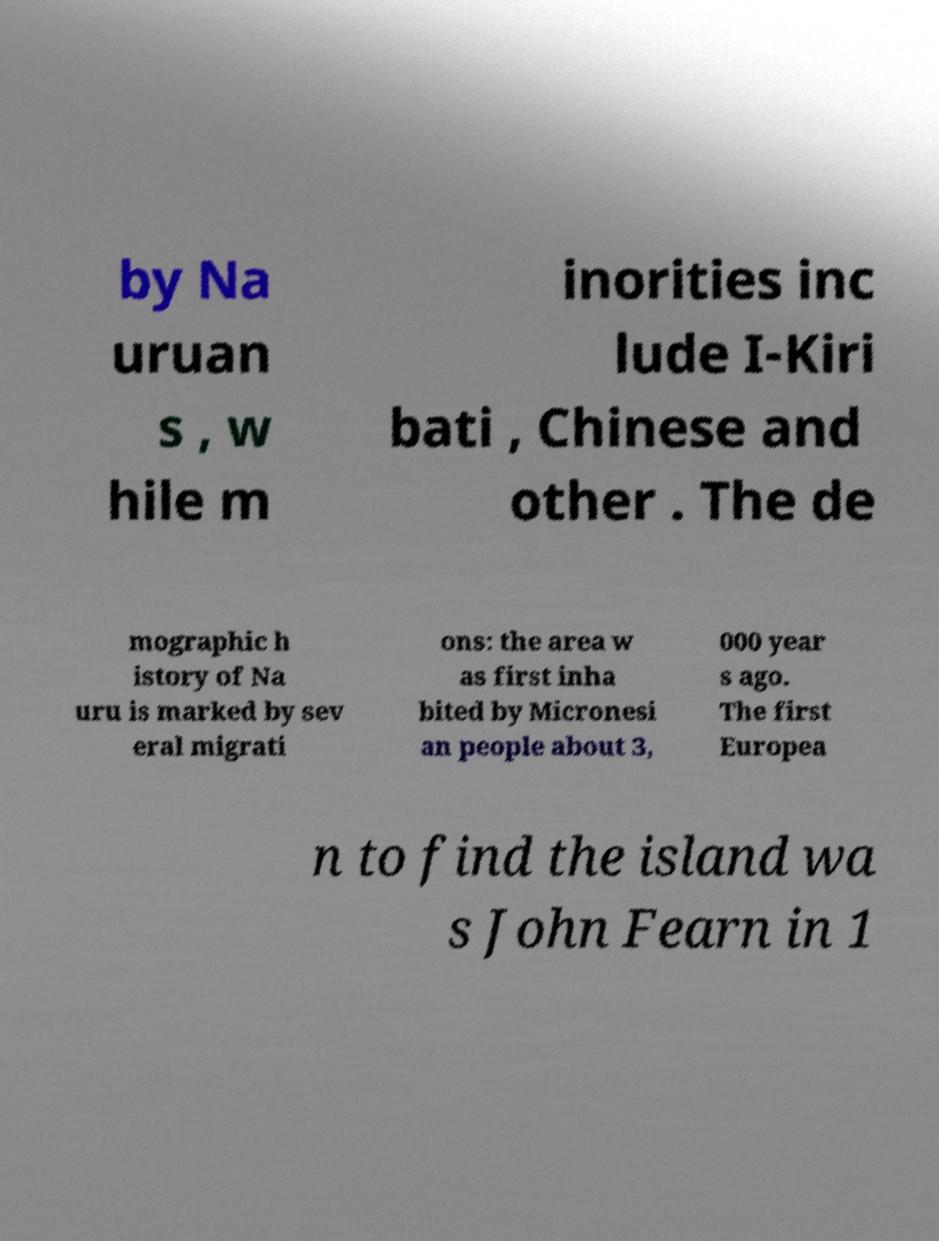Please read and relay the text visible in this image. What does it say? by Na uruan s , w hile m inorities inc lude I-Kiri bati , Chinese and other . The de mographic h istory of Na uru is marked by sev eral migrati ons: the area w as first inha bited by Micronesi an people about 3, 000 year s ago. The first Europea n to find the island wa s John Fearn in 1 